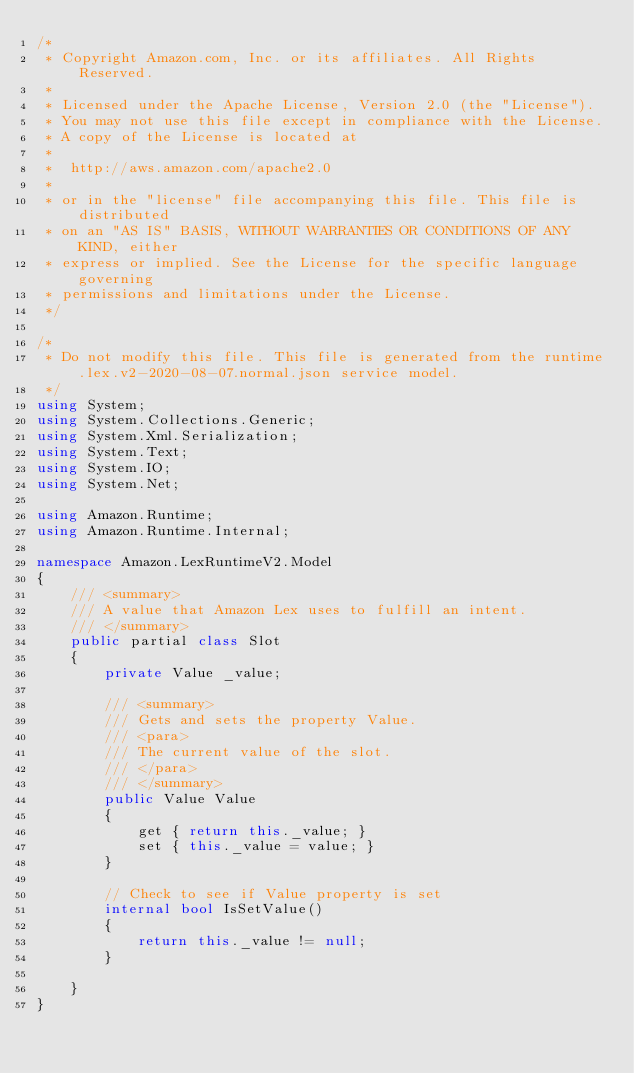<code> <loc_0><loc_0><loc_500><loc_500><_C#_>/*
 * Copyright Amazon.com, Inc. or its affiliates. All Rights Reserved.
 * 
 * Licensed under the Apache License, Version 2.0 (the "License").
 * You may not use this file except in compliance with the License.
 * A copy of the License is located at
 * 
 *  http://aws.amazon.com/apache2.0
 * 
 * or in the "license" file accompanying this file. This file is distributed
 * on an "AS IS" BASIS, WITHOUT WARRANTIES OR CONDITIONS OF ANY KIND, either
 * express or implied. See the License for the specific language governing
 * permissions and limitations under the License.
 */

/*
 * Do not modify this file. This file is generated from the runtime.lex.v2-2020-08-07.normal.json service model.
 */
using System;
using System.Collections.Generic;
using System.Xml.Serialization;
using System.Text;
using System.IO;
using System.Net;

using Amazon.Runtime;
using Amazon.Runtime.Internal;

namespace Amazon.LexRuntimeV2.Model
{
    /// <summary>
    /// A value that Amazon Lex uses to fulfill an intent.
    /// </summary>
    public partial class Slot
    {
        private Value _value;

        /// <summary>
        /// Gets and sets the property Value. 
        /// <para>
        /// The current value of the slot.
        /// </para>
        /// </summary>
        public Value Value
        {
            get { return this._value; }
            set { this._value = value; }
        }

        // Check to see if Value property is set
        internal bool IsSetValue()
        {
            return this._value != null;
        }

    }
}</code> 